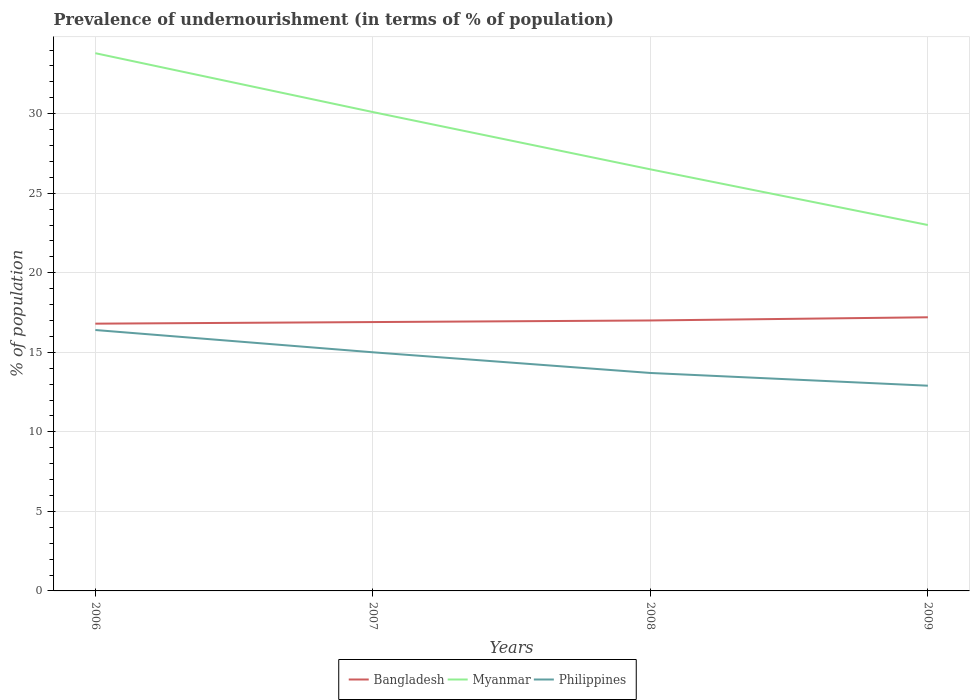How many different coloured lines are there?
Make the answer very short. 3. Across all years, what is the maximum percentage of undernourished population in Philippines?
Offer a very short reply. 12.9. In which year was the percentage of undernourished population in Myanmar maximum?
Your answer should be compact. 2009. What is the total percentage of undernourished population in Bangladesh in the graph?
Ensure brevity in your answer.  -0.3. What is the difference between the highest and the second highest percentage of undernourished population in Bangladesh?
Your answer should be very brief. 0.4. How many lines are there?
Give a very brief answer. 3. How many years are there in the graph?
Ensure brevity in your answer.  4. Are the values on the major ticks of Y-axis written in scientific E-notation?
Your response must be concise. No. Does the graph contain grids?
Provide a succinct answer. Yes. What is the title of the graph?
Your response must be concise. Prevalence of undernourishment (in terms of % of population). What is the label or title of the Y-axis?
Make the answer very short. % of population. What is the % of population in Bangladesh in 2006?
Offer a terse response. 16.8. What is the % of population in Myanmar in 2006?
Keep it short and to the point. 33.8. What is the % of population of Philippines in 2006?
Provide a succinct answer. 16.4. What is the % of population in Bangladesh in 2007?
Provide a short and direct response. 16.9. What is the % of population in Myanmar in 2007?
Provide a short and direct response. 30.1. What is the % of population of Bangladesh in 2008?
Ensure brevity in your answer.  17. What is the % of population in Myanmar in 2008?
Provide a succinct answer. 26.5. What is the % of population in Philippines in 2008?
Your answer should be very brief. 13.7. What is the % of population in Bangladesh in 2009?
Provide a succinct answer. 17.2. What is the % of population in Myanmar in 2009?
Your answer should be compact. 23. Across all years, what is the maximum % of population in Myanmar?
Offer a very short reply. 33.8. Across all years, what is the maximum % of population of Philippines?
Make the answer very short. 16.4. Across all years, what is the minimum % of population of Bangladesh?
Provide a short and direct response. 16.8. Across all years, what is the minimum % of population of Myanmar?
Keep it short and to the point. 23. What is the total % of population of Bangladesh in the graph?
Make the answer very short. 67.9. What is the total % of population in Myanmar in the graph?
Your response must be concise. 113.4. What is the difference between the % of population in Myanmar in 2006 and that in 2007?
Your answer should be very brief. 3.7. What is the difference between the % of population in Bangladesh in 2006 and that in 2009?
Offer a very short reply. -0.4. What is the difference between the % of population of Myanmar in 2006 and that in 2009?
Provide a short and direct response. 10.8. What is the difference between the % of population in Bangladesh in 2007 and that in 2008?
Your answer should be very brief. -0.1. What is the difference between the % of population in Myanmar in 2007 and that in 2008?
Your response must be concise. 3.6. What is the difference between the % of population in Philippines in 2007 and that in 2008?
Your response must be concise. 1.3. What is the difference between the % of population of Bangladesh in 2007 and that in 2009?
Offer a terse response. -0.3. What is the difference between the % of population of Myanmar in 2007 and that in 2009?
Offer a very short reply. 7.1. What is the difference between the % of population of Philippines in 2007 and that in 2009?
Your response must be concise. 2.1. What is the difference between the % of population of Philippines in 2008 and that in 2009?
Your answer should be compact. 0.8. What is the difference between the % of population in Bangladesh in 2006 and the % of population in Philippines in 2007?
Keep it short and to the point. 1.8. What is the difference between the % of population of Myanmar in 2006 and the % of population of Philippines in 2007?
Provide a succinct answer. 18.8. What is the difference between the % of population in Bangladesh in 2006 and the % of population in Myanmar in 2008?
Offer a very short reply. -9.7. What is the difference between the % of population in Bangladesh in 2006 and the % of population in Philippines in 2008?
Your answer should be compact. 3.1. What is the difference between the % of population of Myanmar in 2006 and the % of population of Philippines in 2008?
Offer a very short reply. 20.1. What is the difference between the % of population in Bangladesh in 2006 and the % of population in Myanmar in 2009?
Offer a very short reply. -6.2. What is the difference between the % of population in Myanmar in 2006 and the % of population in Philippines in 2009?
Your answer should be very brief. 20.9. What is the difference between the % of population in Bangladesh in 2007 and the % of population in Philippines in 2008?
Make the answer very short. 3.2. What is the difference between the % of population of Myanmar in 2007 and the % of population of Philippines in 2008?
Keep it short and to the point. 16.4. What is the difference between the % of population of Bangladesh in 2007 and the % of population of Myanmar in 2009?
Ensure brevity in your answer.  -6.1. What is the difference between the % of population in Myanmar in 2007 and the % of population in Philippines in 2009?
Give a very brief answer. 17.2. What is the difference between the % of population in Bangladesh in 2008 and the % of population in Myanmar in 2009?
Your answer should be compact. -6. What is the average % of population in Bangladesh per year?
Provide a short and direct response. 16.98. What is the average % of population of Myanmar per year?
Your answer should be compact. 28.35. In the year 2006, what is the difference between the % of population of Bangladesh and % of population of Philippines?
Provide a short and direct response. 0.4. In the year 2007, what is the difference between the % of population of Bangladesh and % of population of Philippines?
Your answer should be compact. 1.9. In the year 2007, what is the difference between the % of population in Myanmar and % of population in Philippines?
Give a very brief answer. 15.1. In the year 2008, what is the difference between the % of population of Bangladesh and % of population of Philippines?
Offer a very short reply. 3.3. In the year 2008, what is the difference between the % of population of Myanmar and % of population of Philippines?
Provide a succinct answer. 12.8. In the year 2009, what is the difference between the % of population in Myanmar and % of population in Philippines?
Provide a short and direct response. 10.1. What is the ratio of the % of population of Myanmar in 2006 to that in 2007?
Offer a very short reply. 1.12. What is the ratio of the % of population in Philippines in 2006 to that in 2007?
Offer a very short reply. 1.09. What is the ratio of the % of population in Bangladesh in 2006 to that in 2008?
Provide a short and direct response. 0.99. What is the ratio of the % of population in Myanmar in 2006 to that in 2008?
Offer a very short reply. 1.28. What is the ratio of the % of population of Philippines in 2006 to that in 2008?
Offer a very short reply. 1.2. What is the ratio of the % of population of Bangladesh in 2006 to that in 2009?
Ensure brevity in your answer.  0.98. What is the ratio of the % of population of Myanmar in 2006 to that in 2009?
Provide a short and direct response. 1.47. What is the ratio of the % of population in Philippines in 2006 to that in 2009?
Your response must be concise. 1.27. What is the ratio of the % of population of Myanmar in 2007 to that in 2008?
Your answer should be compact. 1.14. What is the ratio of the % of population in Philippines in 2007 to that in 2008?
Provide a short and direct response. 1.09. What is the ratio of the % of population in Bangladesh in 2007 to that in 2009?
Give a very brief answer. 0.98. What is the ratio of the % of population in Myanmar in 2007 to that in 2009?
Your answer should be compact. 1.31. What is the ratio of the % of population in Philippines in 2007 to that in 2009?
Your response must be concise. 1.16. What is the ratio of the % of population in Bangladesh in 2008 to that in 2009?
Offer a very short reply. 0.99. What is the ratio of the % of population of Myanmar in 2008 to that in 2009?
Give a very brief answer. 1.15. What is the ratio of the % of population in Philippines in 2008 to that in 2009?
Offer a very short reply. 1.06. What is the difference between the highest and the second highest % of population of Bangladesh?
Provide a short and direct response. 0.2. What is the difference between the highest and the second highest % of population in Myanmar?
Your response must be concise. 3.7. What is the difference between the highest and the second highest % of population of Philippines?
Your response must be concise. 1.4. What is the difference between the highest and the lowest % of population in Bangladesh?
Your response must be concise. 0.4. What is the difference between the highest and the lowest % of population of Myanmar?
Your answer should be very brief. 10.8. 